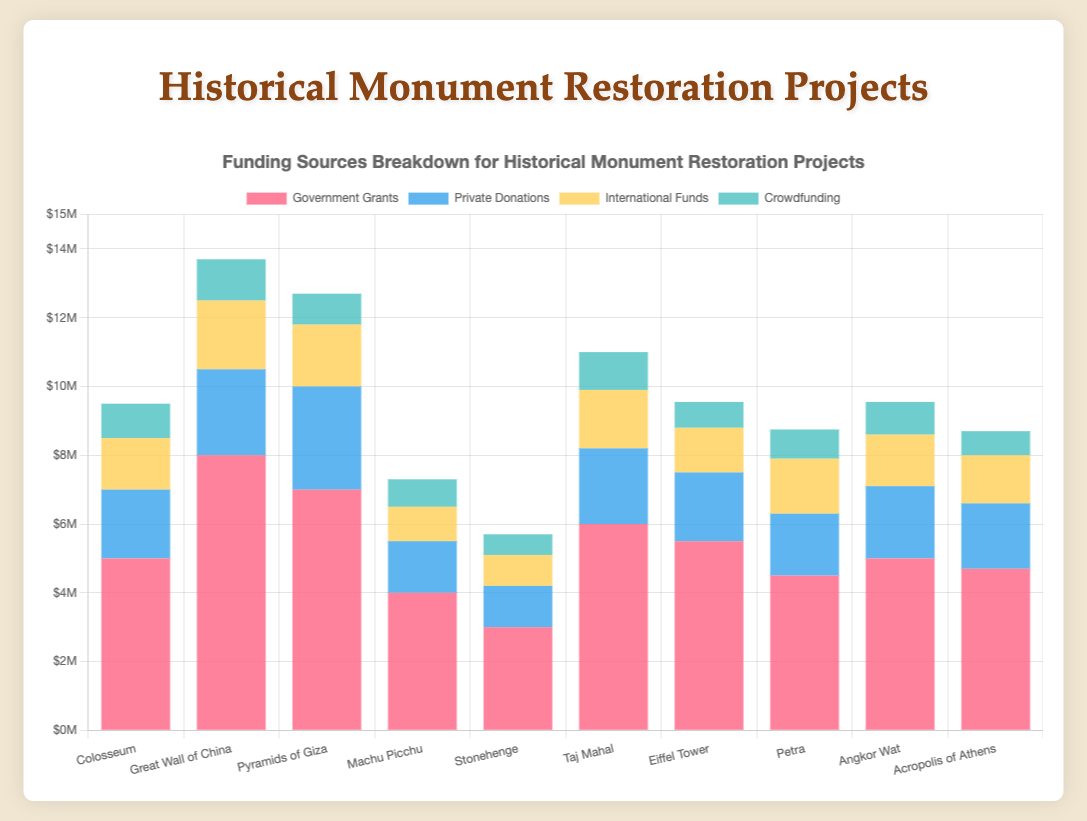Which monument has the highest total funding? To find the monument with the highest total funding, sum up the funding from all sources for each monument and identify the highest amount. The Great Wall of China has the following funding: Government Grants ($8,000,000) + Private Donations ($2,500,000) + International Funds ($2,000,000) + Crowdfunding ($1,200,000), making a total of $13,700,000.
Answer: Great Wall of China Which funding source contributes the most to the restoration of the Pyramids of Giza? For the Pyramids of Giza, compare the values of each funding source: Government Grants ($7,000,000), Private Donations ($3,000,000), International Funds ($1,800,000), and Crowdfunding ($900,000). The Government Grants have the highest contribution.
Answer: Government Grants Is the amount of private donations three times greater for the Great Wall of China compared to Stonehenge? Compare the Private Donations for both monuments: $2,500,000 for the Great Wall of China and $1,200,000 for Stonehenge. Three times $1,200,000 (which is $3,600,000) is more than $2,500,000, so the private donations for the Great Wall of China are not three times greater.
Answer: No Which two monuments have the closest total funding amounts? Sum up the funding from all sources for each monument and compare: Colosseum ($9,000,000), Great Wall of China ($13,700,000), Pyramids of Giza ($11,700,000), Machu Picchu ($7,300,000), Stonehenge ($5,700,000), Taj Mahal ($11,100,000), Eiffel Tower ($9,650,000), Petra ($8,850,000), Angkor Wat ($9,450,000), Acropolis of Athens ($8,500,000). Colosseum ($9,000,000) and Angkor Wat ($9,450,000) have the closest totals, with a difference of $450,000.
Answer: Colosseum and Angkor Wat How does the government grant for the Eiffel Tower compare to the Taj Mahal? Look at the Government Grants for both monuments: Eiffel Tower ($5,500,000) and Taj Mahal ($6,000,000). The Eiffel Tower receives $500,000 less in government grants compared to the Taj Mahal.
Answer: Taj Mahal How much more in International Funds does the Great Wall of China receive compared to Angkor Wat? Compare the International Funds for both monuments: Great Wall of China ($2,000,000) and Angkor Wat ($1,500,000). The Great Wall of China receives $500,000 more.
Answer: $500,000 more What is the combined total of Private Donations for the Colosseum and Acropolis of Athens? Sum the Private Donations for both monuments: Colosseum ($2,000,000) and Acropolis of Athens ($1,900,000). The total is $3,900,000.
Answer: $3,900,000 Which funding source has the smallest contribution to the restoration of Machu Picchu? Compare the contributions of all funding sources for Machu Picchu: Government Grants ($4,000,000), Private Donations ($1,500,000), International Funds ($1,000,000), and Crowdfunding ($800,000). Crowdfunding provides the smallest contribution of $800,000.
Answer: Crowdfunding 